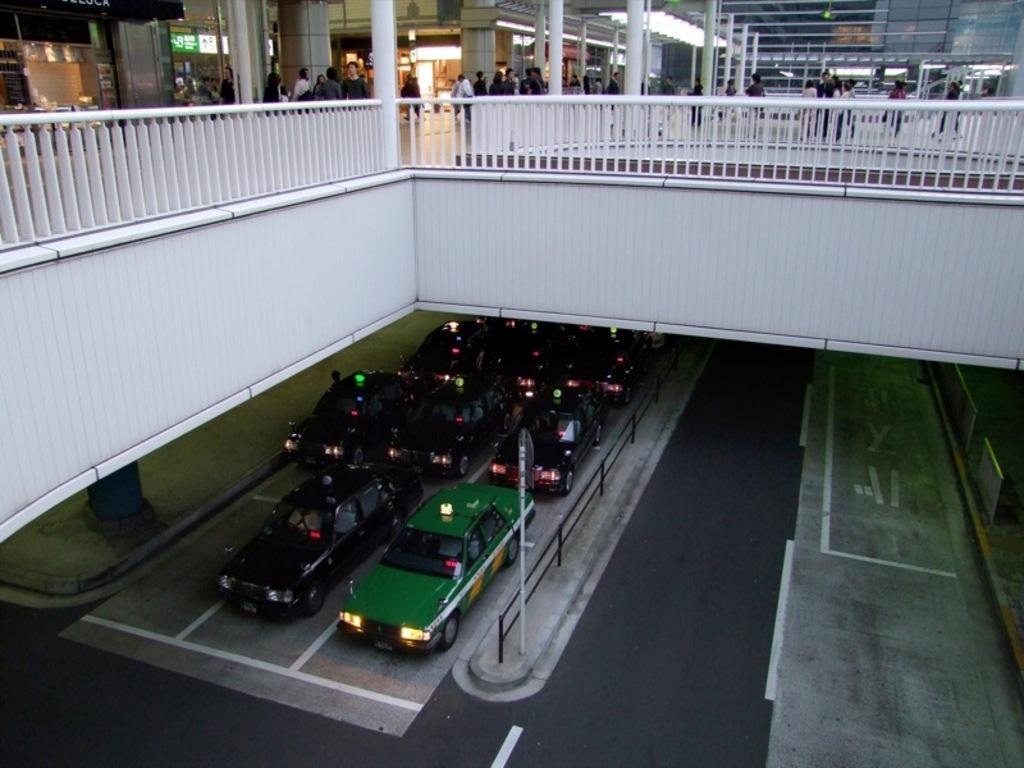Describe this image in one or two sentences. In this image there are few cars at the bottom. At the top there is a floor on which there are so many people who are walking on it. In between them there are pillars. There are stores on the floor. 